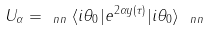<formula> <loc_0><loc_0><loc_500><loc_500>U _ { \alpha } = _ { \ n n } \langle i \theta _ { 0 } | e ^ { 2 \alpha y ( \tau ) } | i \theta _ { 0 } \rangle _ { \ n n }</formula> 